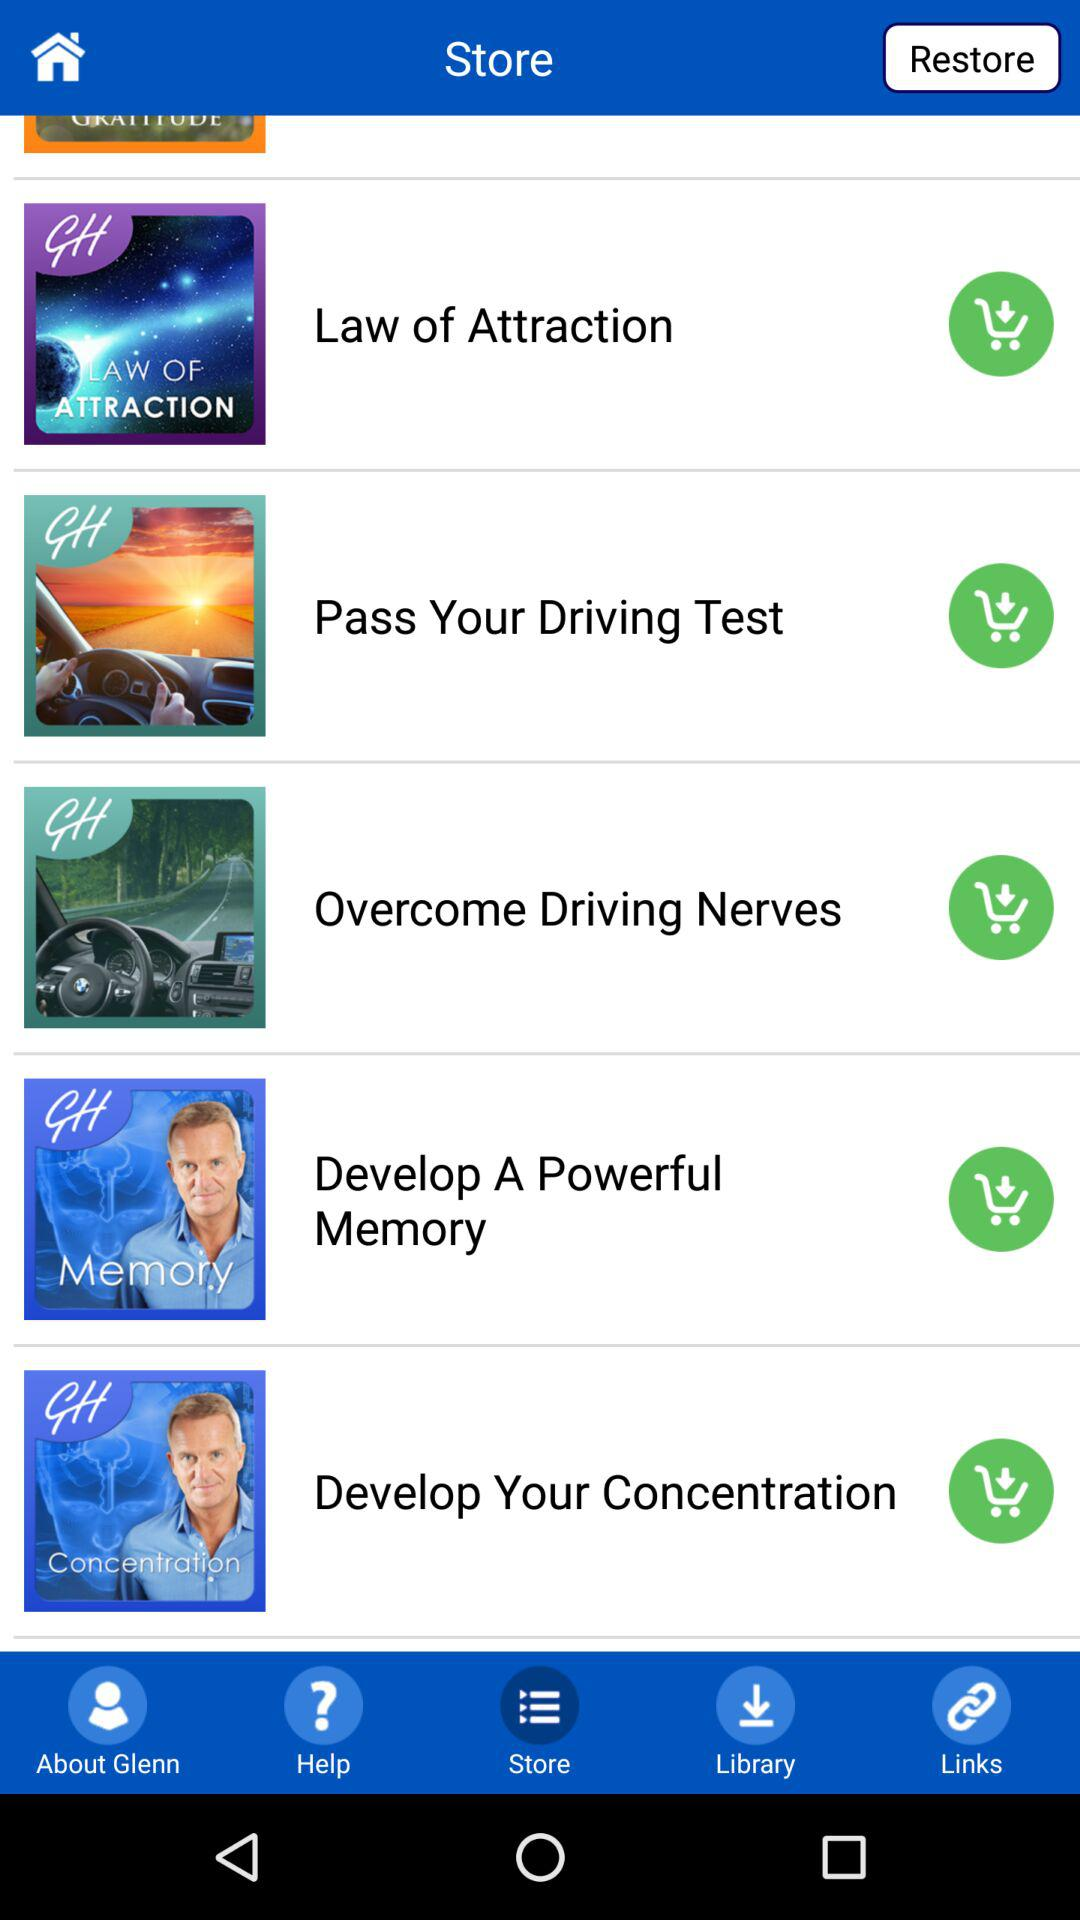Which option has been selected? The option that has been selected is "Store". 